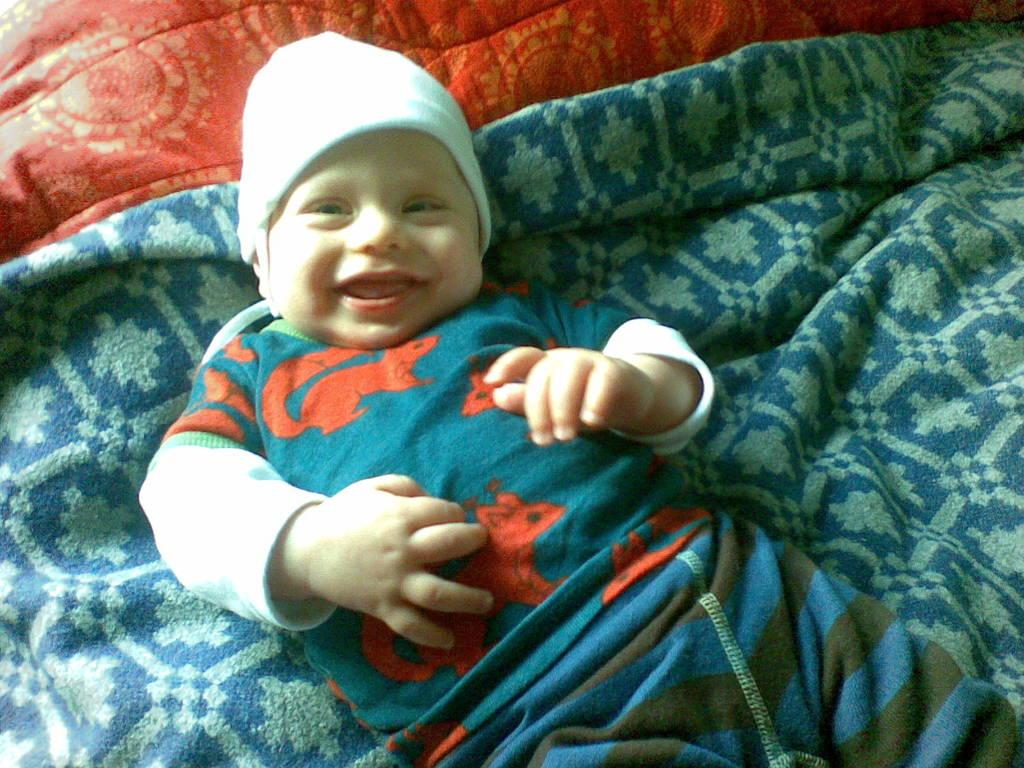What is the main subject of the picture? The main subject of the picture is a baby. Where is the baby located in the image? The baby is lying on a blanket. What is the baby's expression in the picture? The baby is smiling. What type of card is the baby holding in the image? There is no card present in the image; the baby is lying on a blanket and smiling. 